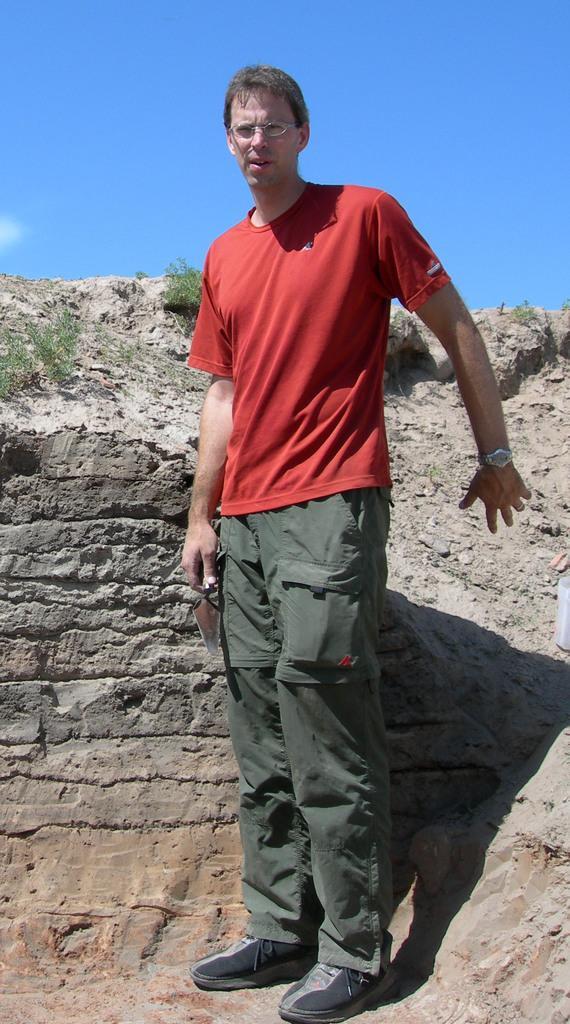How would you summarize this image in a sentence or two? In this image I can see a man is standing. In the background, I can see the sky. 